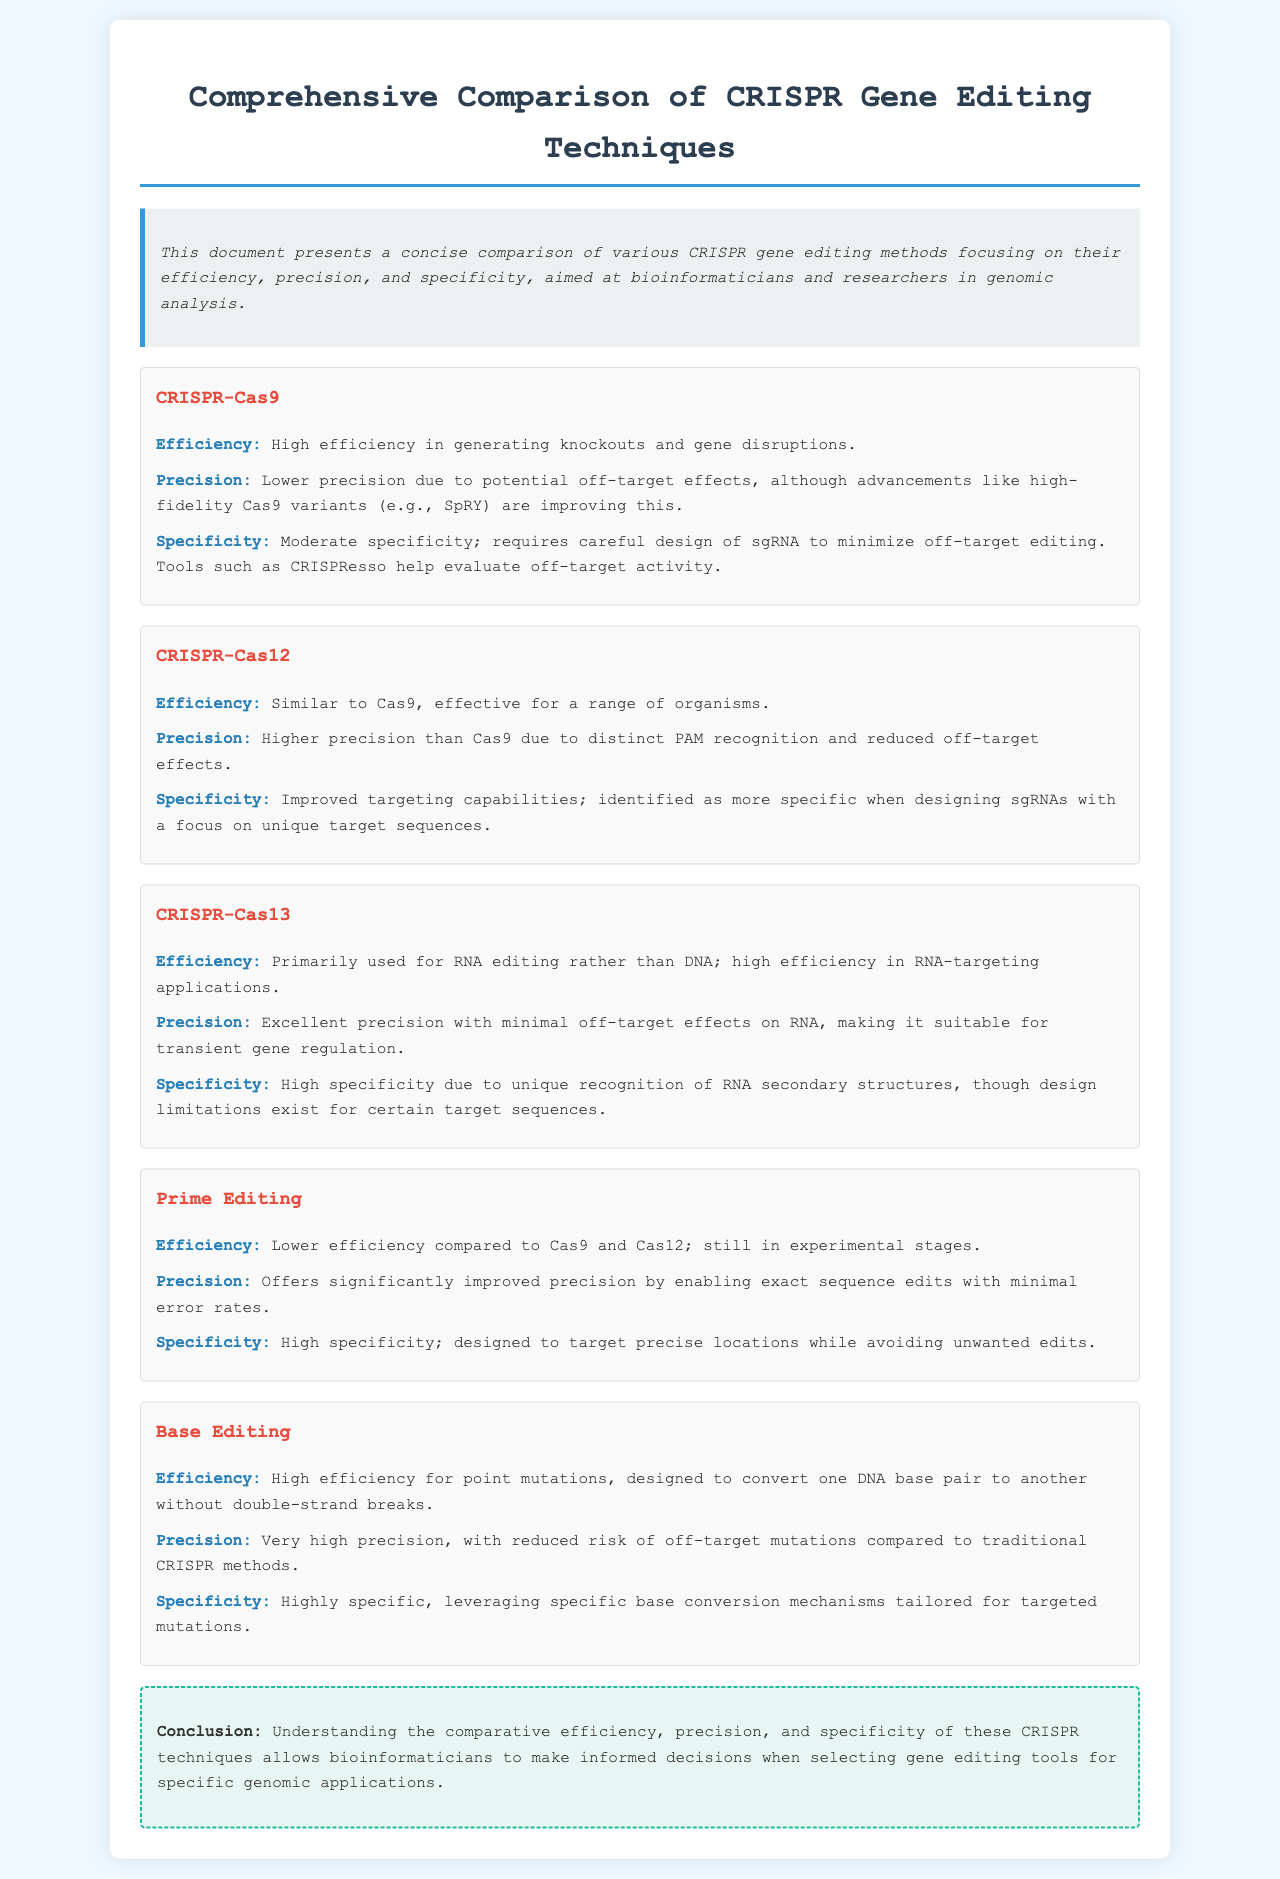What is the main purpose of this document? The document presents a comparison of various CRISPR gene editing methods, focusing on efficiency, precision, and specificity, aimed at bioinformaticians and researchers.
Answer: Comparison of CRISPR gene editing methods What gene editing technique has the highest efficiency for point mutations? The document states that Base Editing has high efficiency for point mutations, designed to convert one DNA base pair to another.
Answer: Base Editing Which CRISPR technique offers significantly improved precision? The document specifies that Prime Editing offers significantly improved precision by enabling exact sequence edits with minimal error rates.
Answer: Prime Editing What is the specificity level of CRISPR-Cas12? The document indicates that CRISPR-Cas12 has improved targeting capabilities and is identified as more specific when designing sgRNAs.
Answer: More specific Which technique is primarily used for RNA editing? The document mentions that CRISPR-Cas13 is primarily used for RNA editing rather than DNA.
Answer: CRISPR-Cas13 What is the efficiency comparison of Prime Editing to CRISPR-Cas9 and Cas12? The document notes that Prime Editing has lower efficiency compared to Cas9 and Cas12.
Answer: Lower efficiency What does the conclusion emphasize about understanding CRISPR techniques? The conclusion emphasizes that understanding the comparative efficiency, precision, and specificity allows bioinformaticians to make informed decisions when selecting gene editing tools.
Answer: Informed decisions How is the precision of Base Editing described? The document describes the precision of Base Editing as very high, with reduced risk of off-target mutations compared to traditional methods.
Answer: Very high precision 